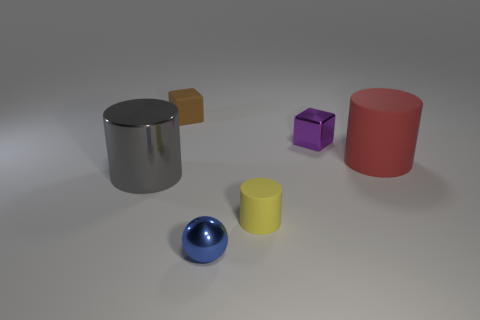What shape is the blue metal thing that is the same size as the yellow rubber cylinder?
Ensure brevity in your answer.  Sphere. Does the object that is in front of the yellow cylinder have the same material as the gray cylinder?
Your answer should be compact. Yes. The large red rubber thing has what shape?
Offer a terse response. Cylinder. What number of yellow things are either balls or cylinders?
Your answer should be compact. 1. What number of other objects are the same material as the small purple block?
Your answer should be very brief. 2. Does the object right of the tiny purple shiny cube have the same shape as the large gray object?
Ensure brevity in your answer.  Yes. Is there a gray metallic cylinder?
Your response must be concise. Yes. Is there any other thing that has the same shape as the yellow matte object?
Ensure brevity in your answer.  Yes. Are there more large gray metallic things that are behind the purple metallic object than brown rubber things?
Offer a very short reply. No. Are there any rubber cylinders in front of the large red object?
Your response must be concise. Yes. 